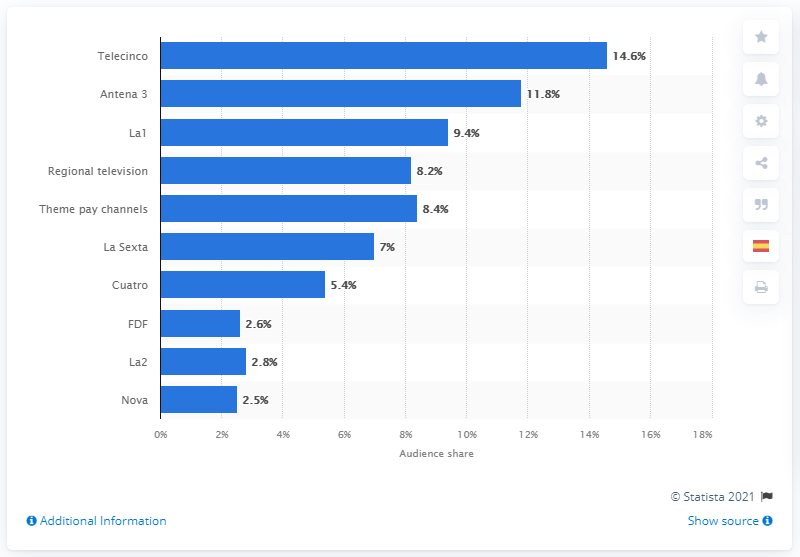Highlight a few significant elements in this photo. Atresmedia's Antena 3 captured 11.8% of the total audience share in . In 2019, Mediaset and Atresmedia generated a combined revenue of 11.8 billion euros. 